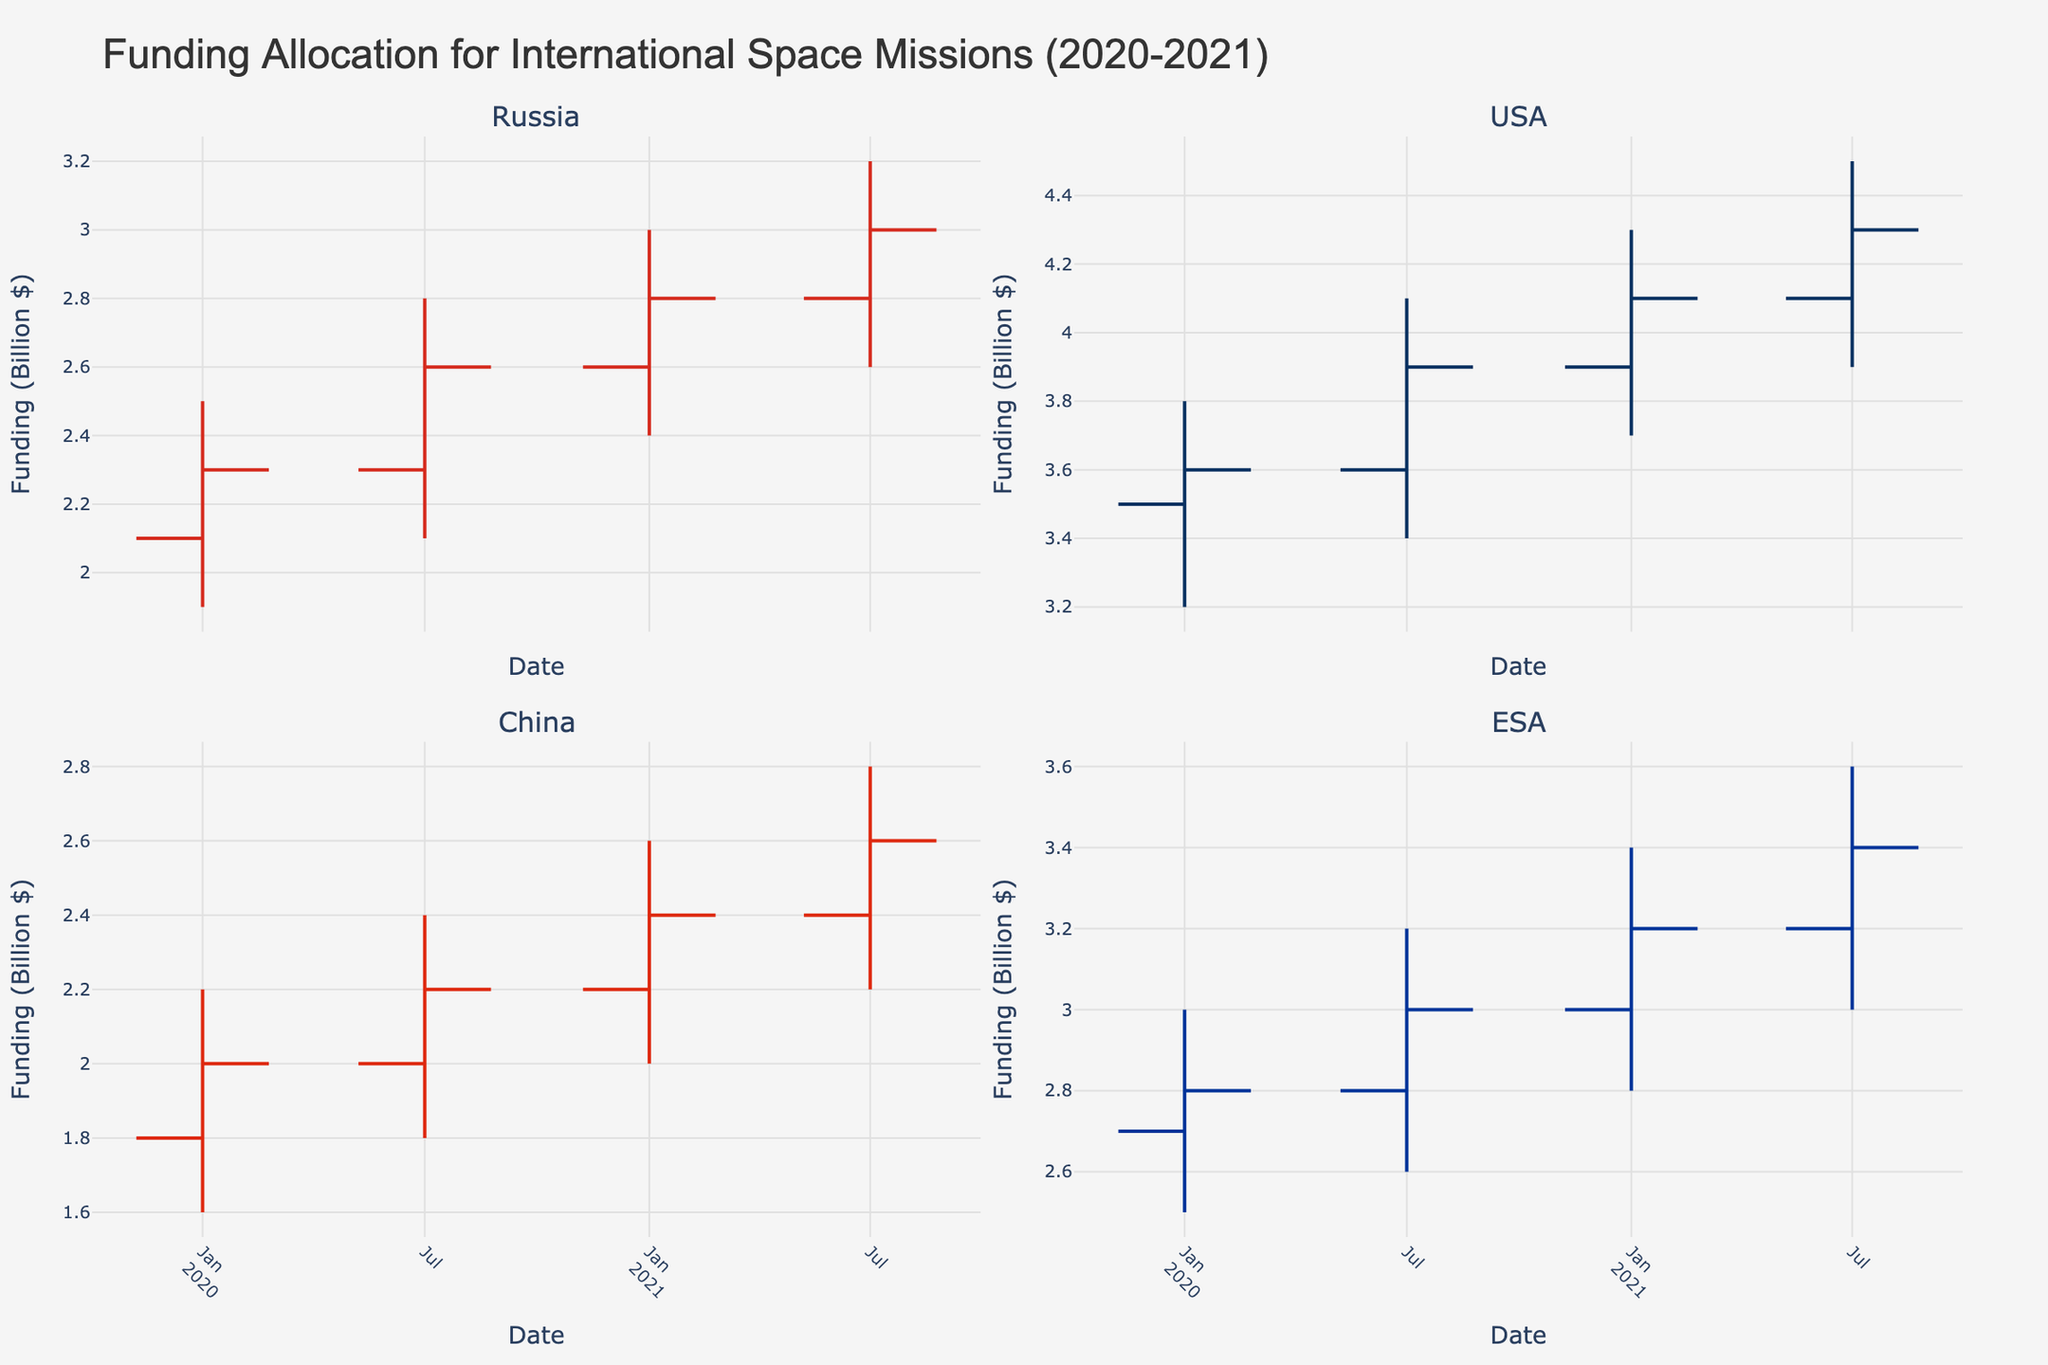what is the title of the figure? The title is located at the top center of the figure and provides a description of the plot. It reads "Funding Allocation for International Space Missions (2020-2021)".
Answer: Funding Allocation for International Space Missions (2020-2021) How many countries' funding allocations are shown in the figure? The figure consists of 4 subplots, each representing a country. The titles of each subplot identify the countries.
Answer: Four (Russia, USA, China, and ESA) Which country shows the highest funding in January 2021? By comparing the 'High' value in January 2021 across all subplots, we see that the USA has the highest 'High' value, reaching 4.3 billion dollars.
Answer: USA Between January 2020 and July 2021, how did Russia's funding change? Looking at the OHLC chart for Russia, we see that the funding increased from 2.3 billion dollars in January 2020 (Close) to 3.0 billion dollars in July 2021 (Close).
Answer: Increased Is there any country whose closing funding values consistently increased over the four time periods? By observing all subplots for the closing values at each time period, we see that the ESA's closing values consistently increased from 2.8 billion dollars in Jan 2020 to 3.4 billion dollars in July 2021.
Answer: ESA During which period did China experience the largest range difference between its high and low funding values? In the OHLC chart for China, the range difference can be determined by subtracting the 'Low' values from the 'High' values. The largest range difference is seen in January 2020 which is (2.2 - 1.6) = 0.6 billion dollars.
Answer: January 2020 Compare the closing funding values of ESA and Russia in July 2021. Which one is higher? From the OHLC charts, ESA has a closing value of 3.4 billion dollars, whereas Russia has a closing value of 3.0 billion dollars. So, ESA's closing funding value is higher.
Answer: ESA What was the closing funding allocation of the USA in July 2021? In the OHLC chart for the USA, the final value for July 2021 is the closing funding value, which is 4.3 billion dollars.
Answer: 4.3 billion dollars For which country and time period did the opening funding value match the lowest funding value exactly? The OHLC chart shows that for China's January 2020 and July 2020 periods, the 'Open' value matches the 'Low' value. Both are 1.8 billion dollars for January 2020, and 2.0 billion dollars for July 2020.
Answer: China (January 2020) 